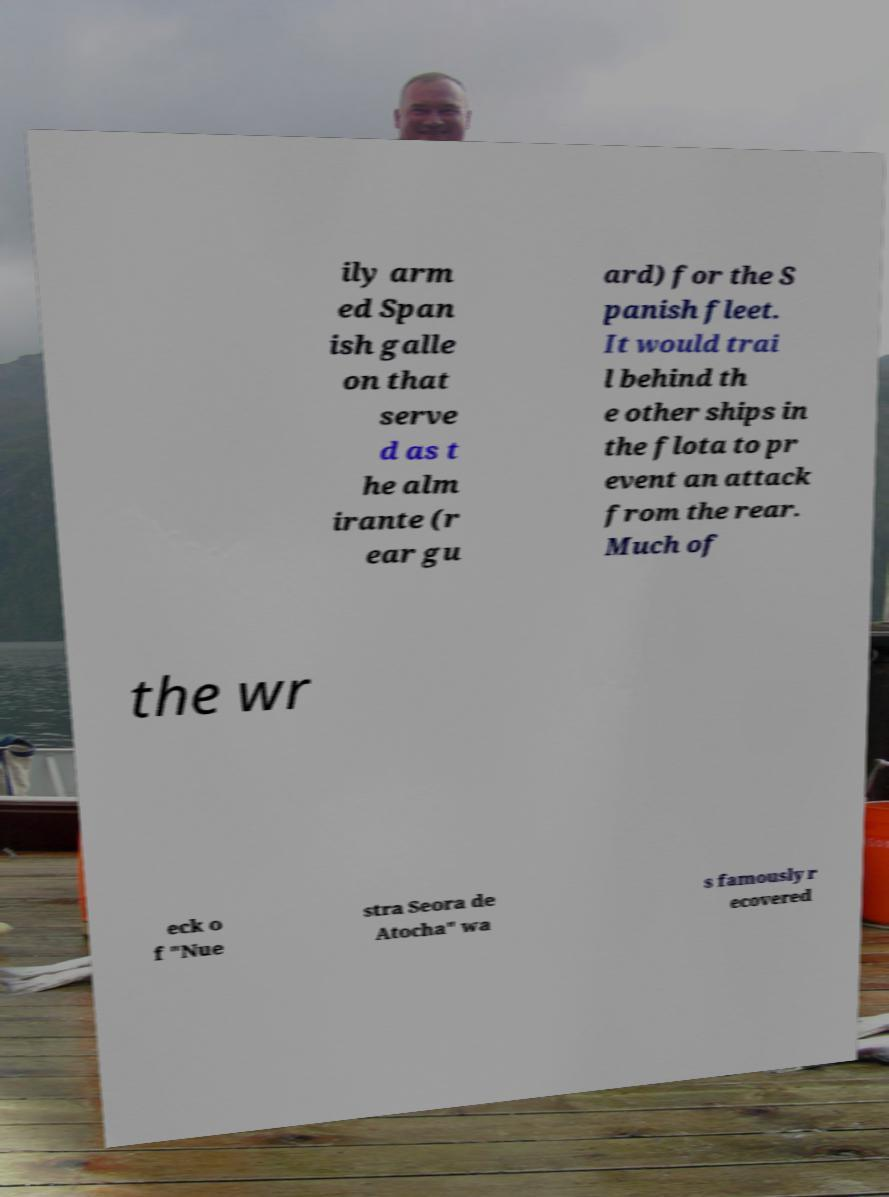Please read and relay the text visible in this image. What does it say? ily arm ed Span ish galle on that serve d as t he alm irante (r ear gu ard) for the S panish fleet. It would trai l behind th e other ships in the flota to pr event an attack from the rear. Much of the wr eck o f "Nue stra Seora de Atocha" wa s famously r ecovered 